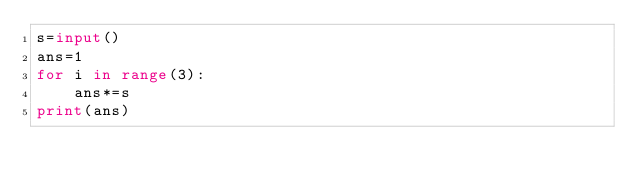Convert code to text. <code><loc_0><loc_0><loc_500><loc_500><_Python_>s=input()
ans=1
for i in range(3):
	ans*=s
print(ans)
</code> 